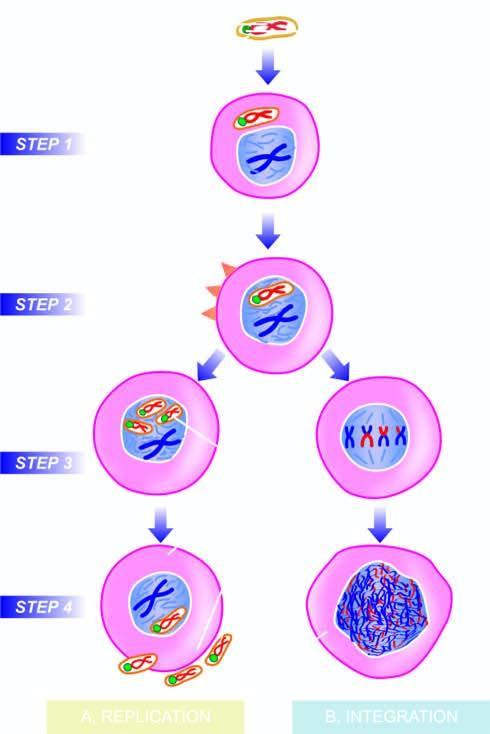re removal of suture formed?
Answer the question using a single word or phrase. No 